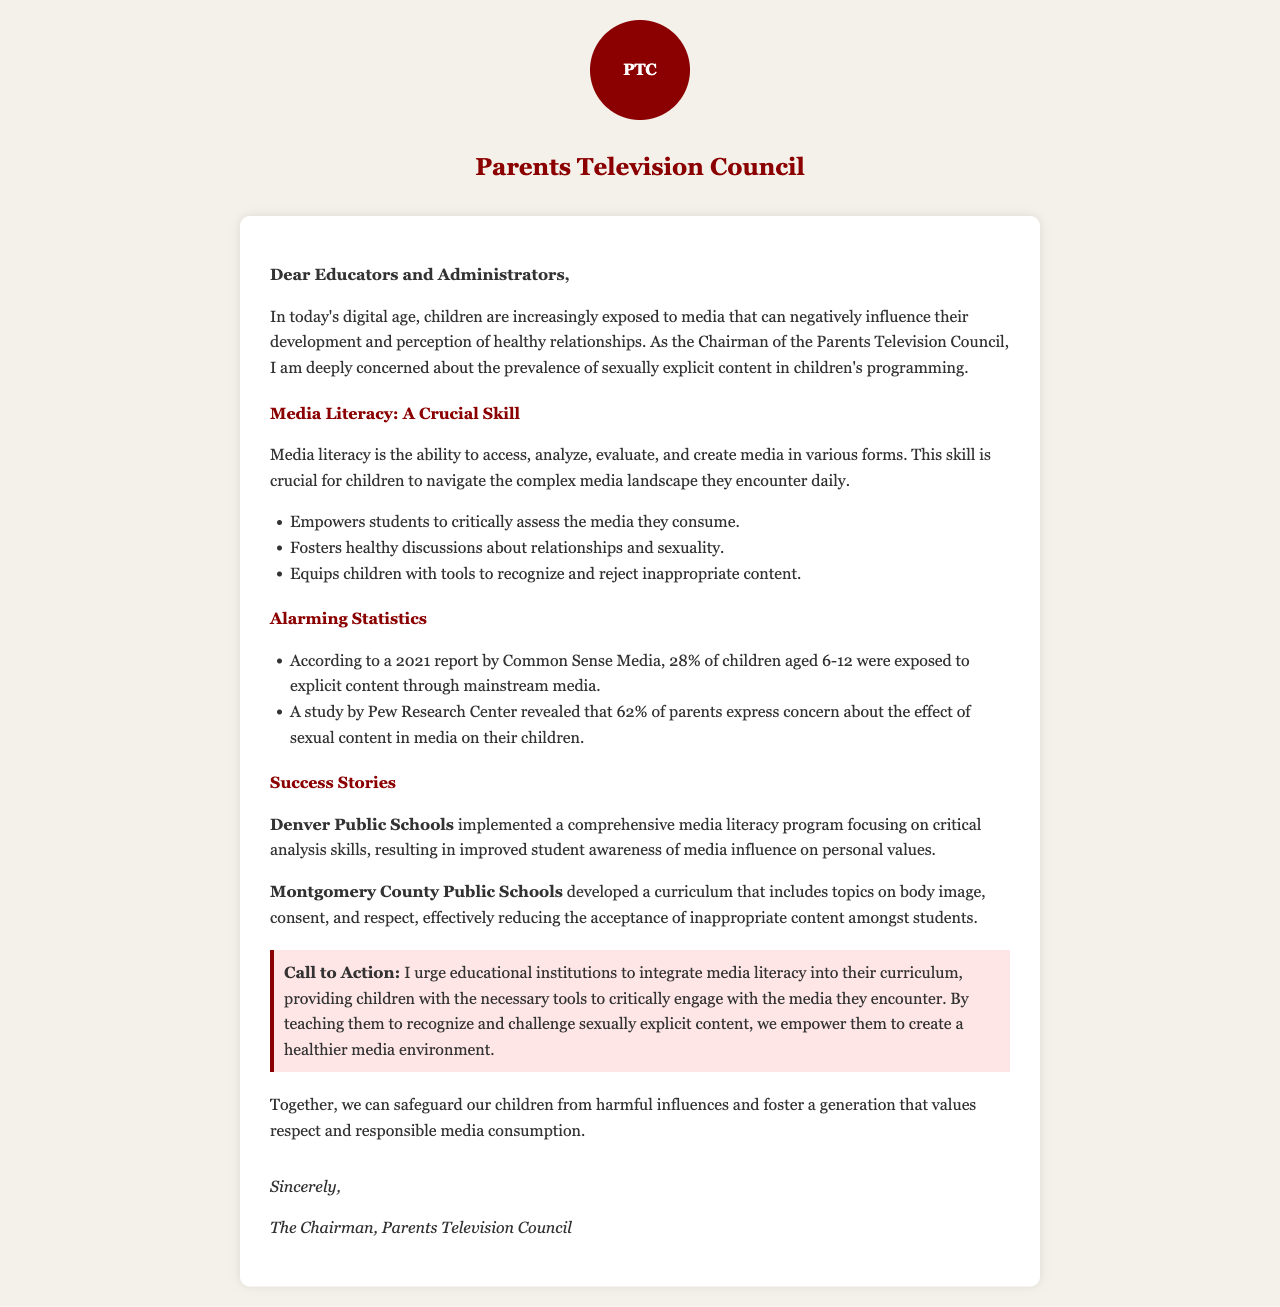what is the main concern of the Chairman of the Parents Television Council? The Chairman expresses concern about the prevalence of sexually explicit content in children's programming.
Answer: sexually explicit content what is the definition of media literacy provided in the letter? Media literacy is described as the ability to access, analyze, evaluate, and create media in various forms.
Answer: ability to access, analyze, evaluate, and create media what percentage of children aged 6-12 were exposed to explicit content according to a 2021 report? The report states that 28% of children aged 6-12 were exposed to explicit content through mainstream media.
Answer: 28% which school district developed a curriculum that includes topics on body image, consent, and respect? The document mentions Montgomery County Public Schools as the district that developed such a curriculum.
Answer: Montgomery County Public Schools what is the call to action in the letter? The call to action urges educational institutions to integrate media literacy into their curriculum.
Answer: integrate media literacy into their curriculum how many parents express concern about the effect of sexual content in media on their children, according to a Pew Research Center study? The study revealed that 62% of parents express concern about this issue.
Answer: 62% what is one benefit of media literacy mentioned in the document? One benefit mentioned is that it empowers students to critically assess the media they consume.
Answer: empowers students to critically assess media which city’s public schools had improved student awareness due to a media literacy program? Denver Public Schools is mentioned as having implemented a comprehensive media literacy program.
Answer: Denver Public Schools 